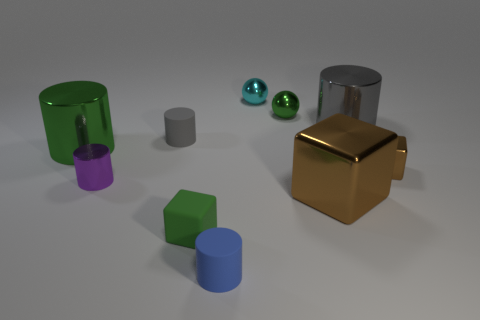Subtract all green cylinders. How many cylinders are left? 4 Subtract all small gray matte cylinders. How many cylinders are left? 4 Subtract all yellow cylinders. Subtract all cyan balls. How many cylinders are left? 5 Subtract all balls. How many objects are left? 8 Add 9 tiny purple cylinders. How many tiny purple cylinders exist? 10 Subtract 0 yellow balls. How many objects are left? 10 Subtract all tiny metallic things. Subtract all cyan metal balls. How many objects are left? 5 Add 9 small green rubber blocks. How many small green rubber blocks are left? 10 